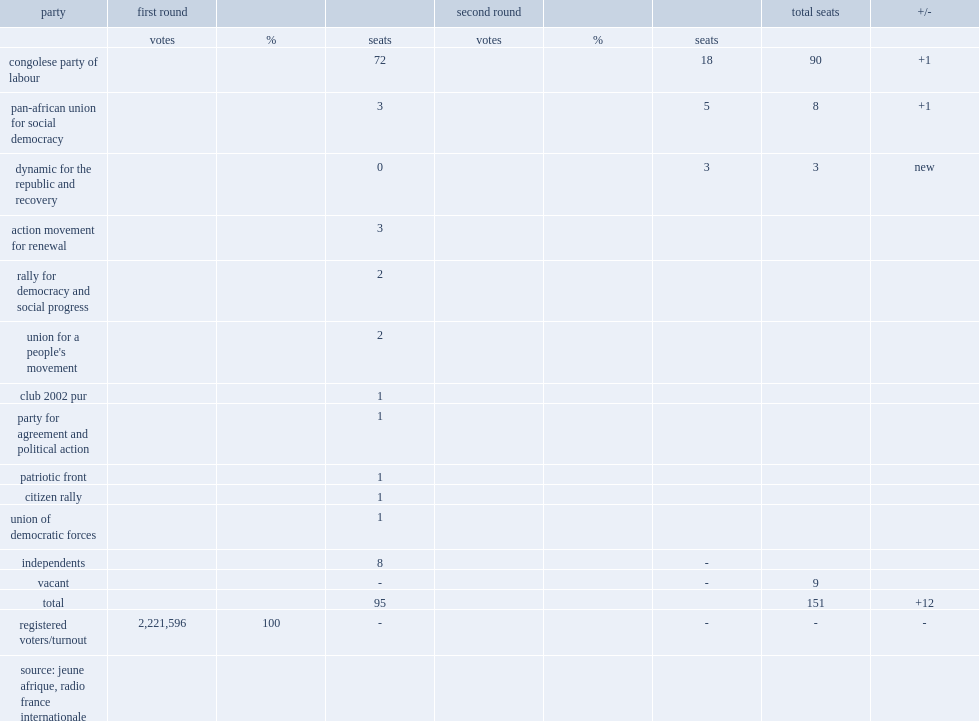How many members were elected using the two-round system? 151.0. 